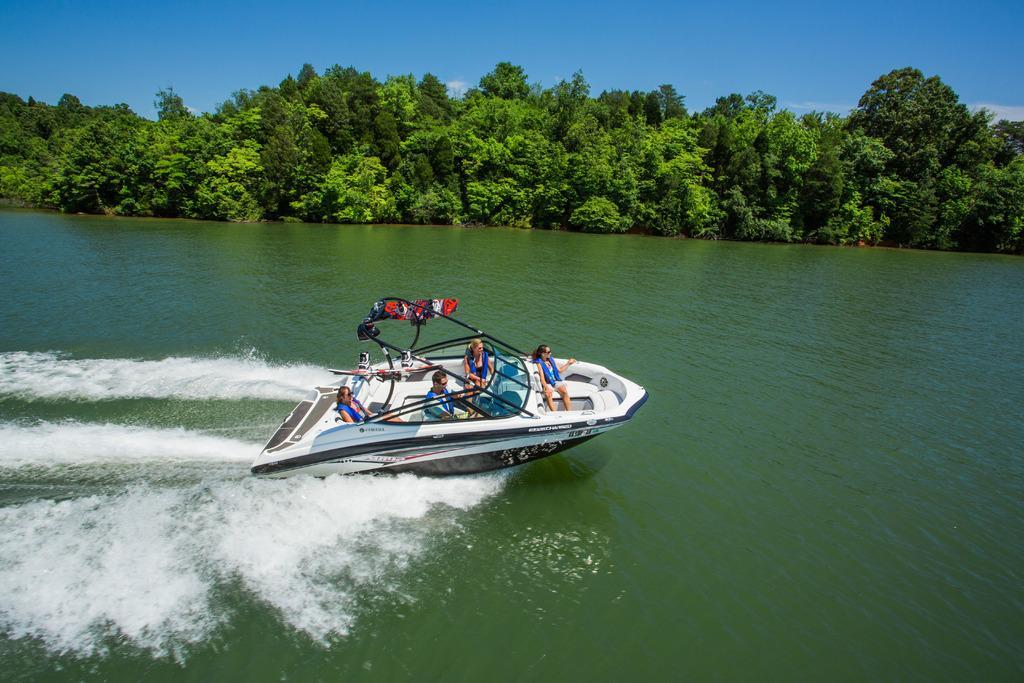Could you give a brief overview of what you see in this image? In the center of the image we can see a steamer boat on the water and there are people sitting in the boat. In the background there are trees and sky. 